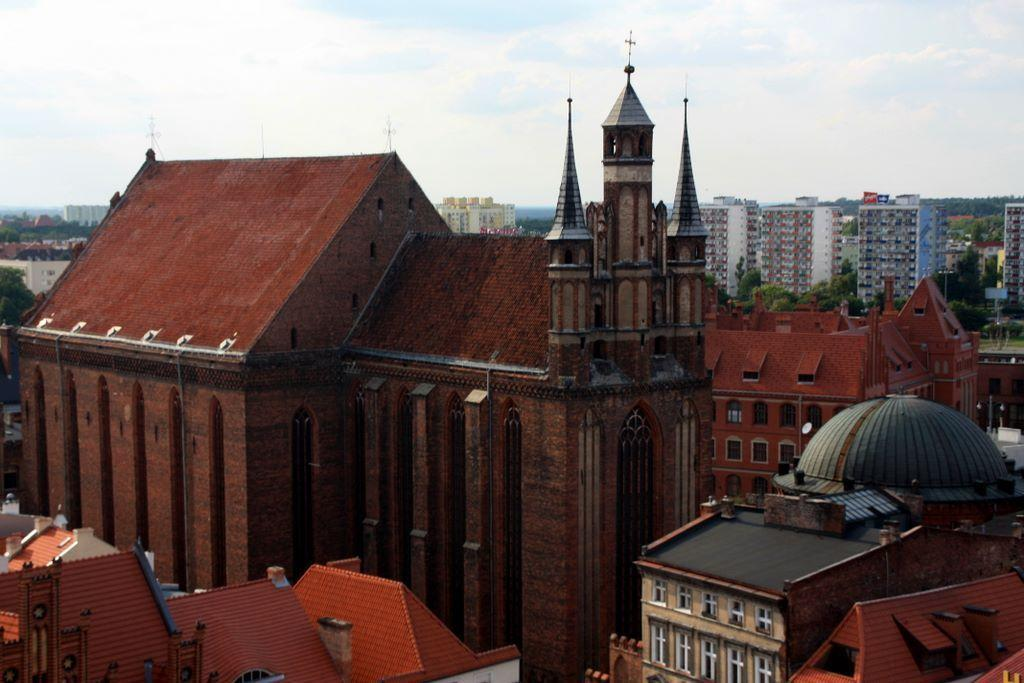What color are the buildings on the right side of the image? The buildings in the image are red. Where are the red buildings located in the image? The red buildings are on the right side of the image. Can you describe the size of the buildings in the image? The buildings in the image are big. What is visible at the top of the image? The sky is visible at the top of the image. What type of jewel can be seen in the image? There is no jewel present in the image. What kind of produce is being harvested in the image? There is no produce or harvesting activity depicted in the image. 